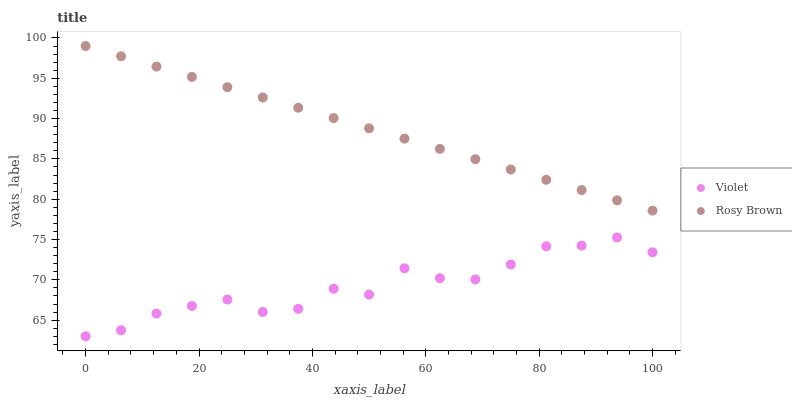Does Violet have the minimum area under the curve?
Answer yes or no. Yes. Does Rosy Brown have the maximum area under the curve?
Answer yes or no. Yes. Does Violet have the maximum area under the curve?
Answer yes or no. No. Is Rosy Brown the smoothest?
Answer yes or no. Yes. Is Violet the roughest?
Answer yes or no. Yes. Is Violet the smoothest?
Answer yes or no. No. Does Violet have the lowest value?
Answer yes or no. Yes. Does Rosy Brown have the highest value?
Answer yes or no. Yes. Does Violet have the highest value?
Answer yes or no. No. Is Violet less than Rosy Brown?
Answer yes or no. Yes. Is Rosy Brown greater than Violet?
Answer yes or no. Yes. Does Violet intersect Rosy Brown?
Answer yes or no. No. 